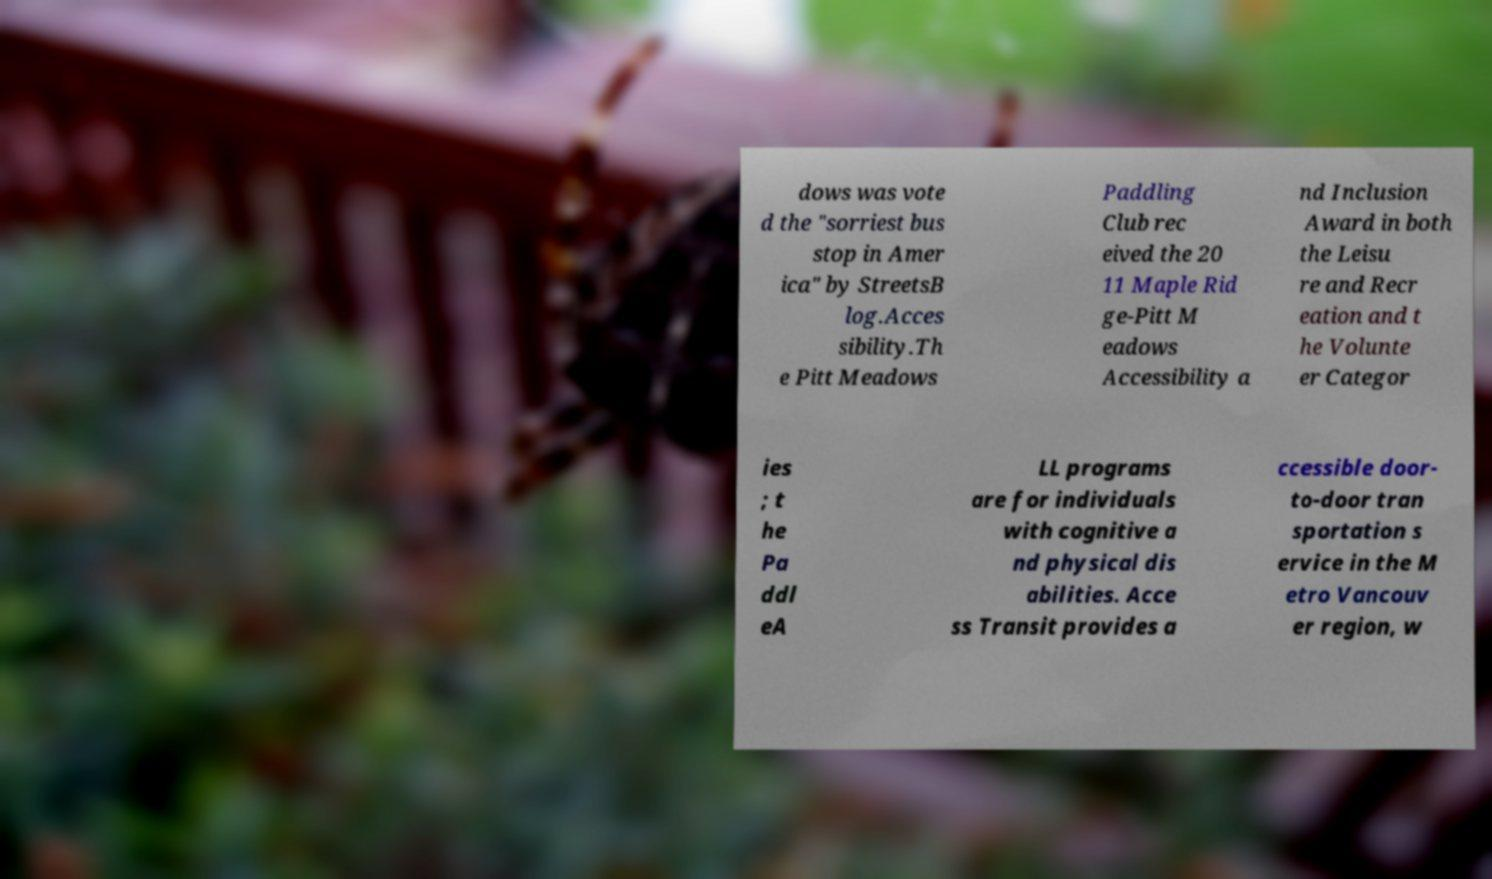Please read and relay the text visible in this image. What does it say? dows was vote d the "sorriest bus stop in Amer ica" by StreetsB log.Acces sibility.Th e Pitt Meadows Paddling Club rec eived the 20 11 Maple Rid ge-Pitt M eadows Accessibility a nd Inclusion Award in both the Leisu re and Recr eation and t he Volunte er Categor ies ; t he Pa ddl eA LL programs are for individuals with cognitive a nd physical dis abilities. Acce ss Transit provides a ccessible door- to-door tran sportation s ervice in the M etro Vancouv er region, w 